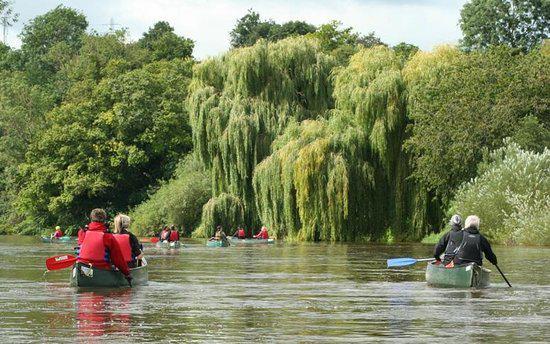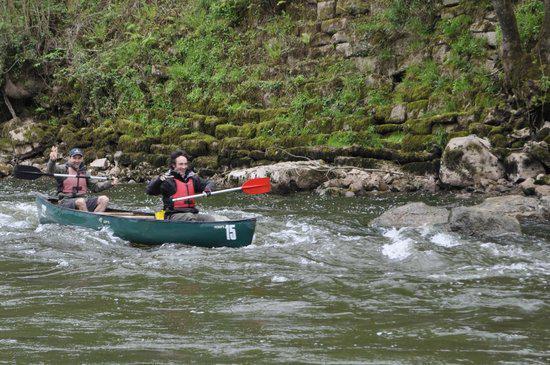The first image is the image on the left, the second image is the image on the right. Given the left and right images, does the statement "The right image shows red oars." hold true? Answer yes or no. Yes. 